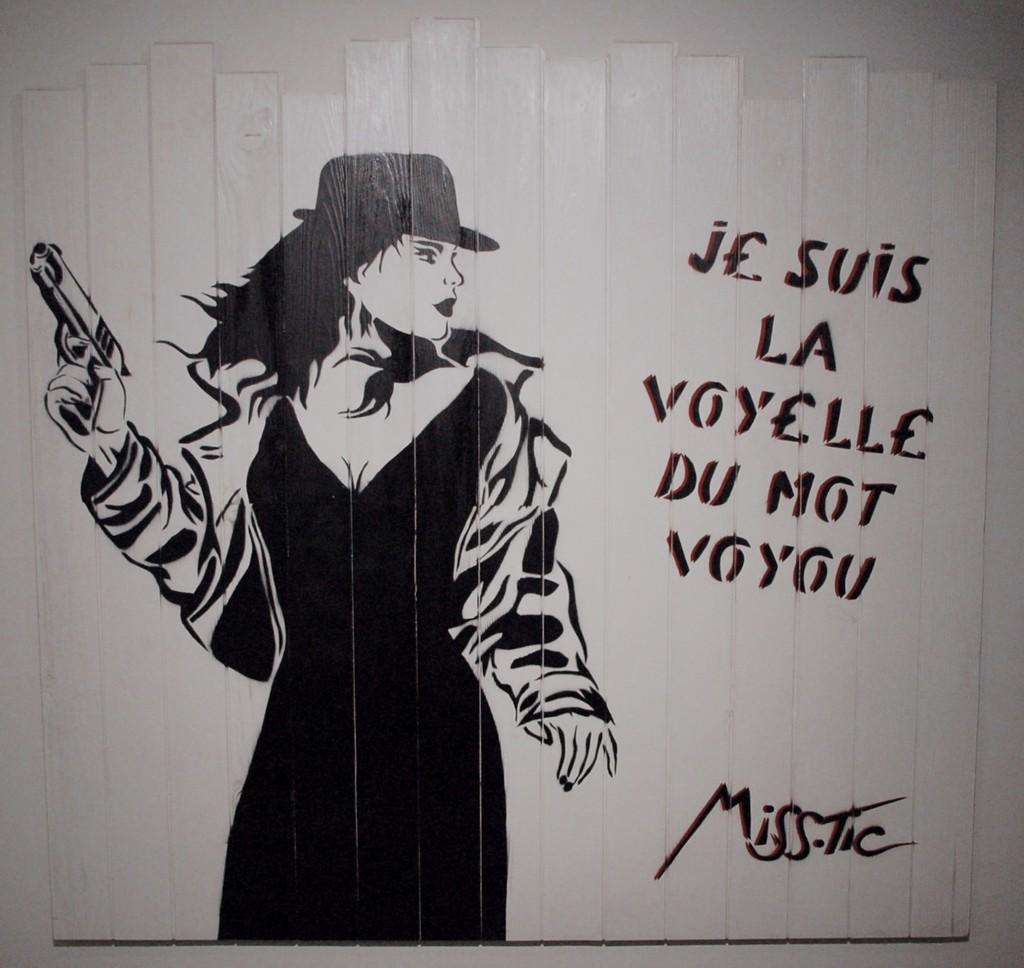What is depicted in the painting in the image? There is a painting of a woman in the image. What is the woman in the painting holding? The woman in the painting is holding a gun. Where is the painting located in the image? The painting is on a white wall. What else can be seen on the wall in the image? There is writing on the wall in the image. How many eggs are visible in the image? There are no eggs present in the image. What type of action is the judge performing in the image? There is no judge or action involving a judge present in the image. 